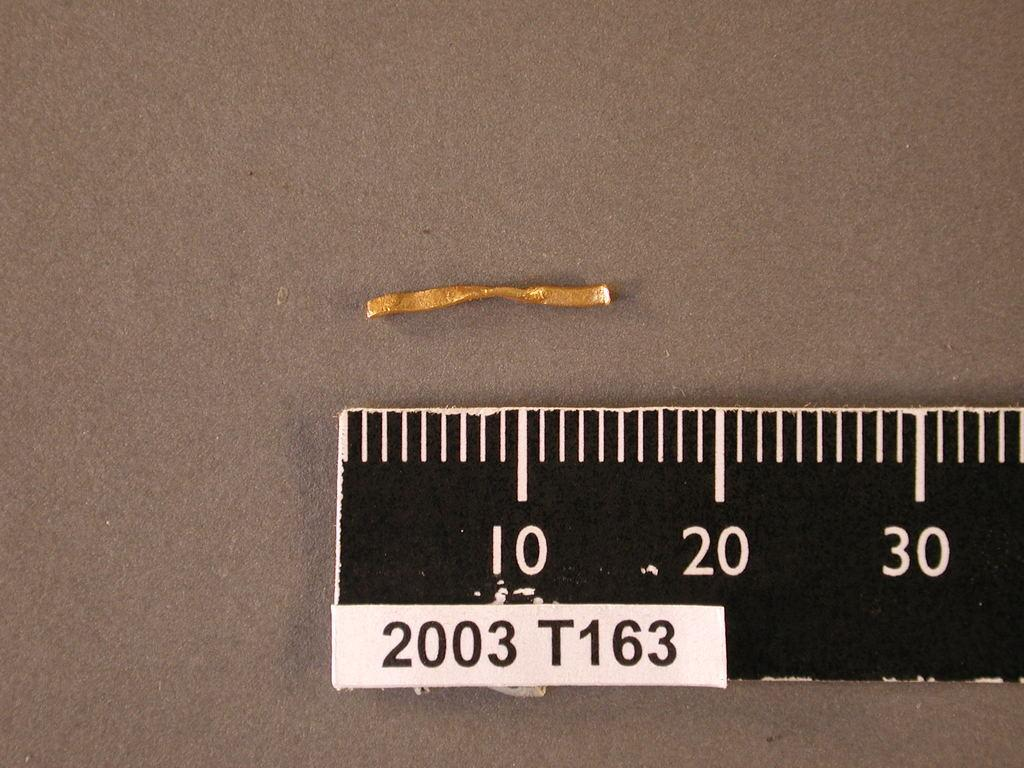<image>
Create a compact narrative representing the image presented. A brown piece of material measures between 10 and 20. 